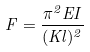Convert formula to latex. <formula><loc_0><loc_0><loc_500><loc_500>F = \frac { \pi ^ { 2 } E I } { ( K l ) ^ { 2 } }</formula> 